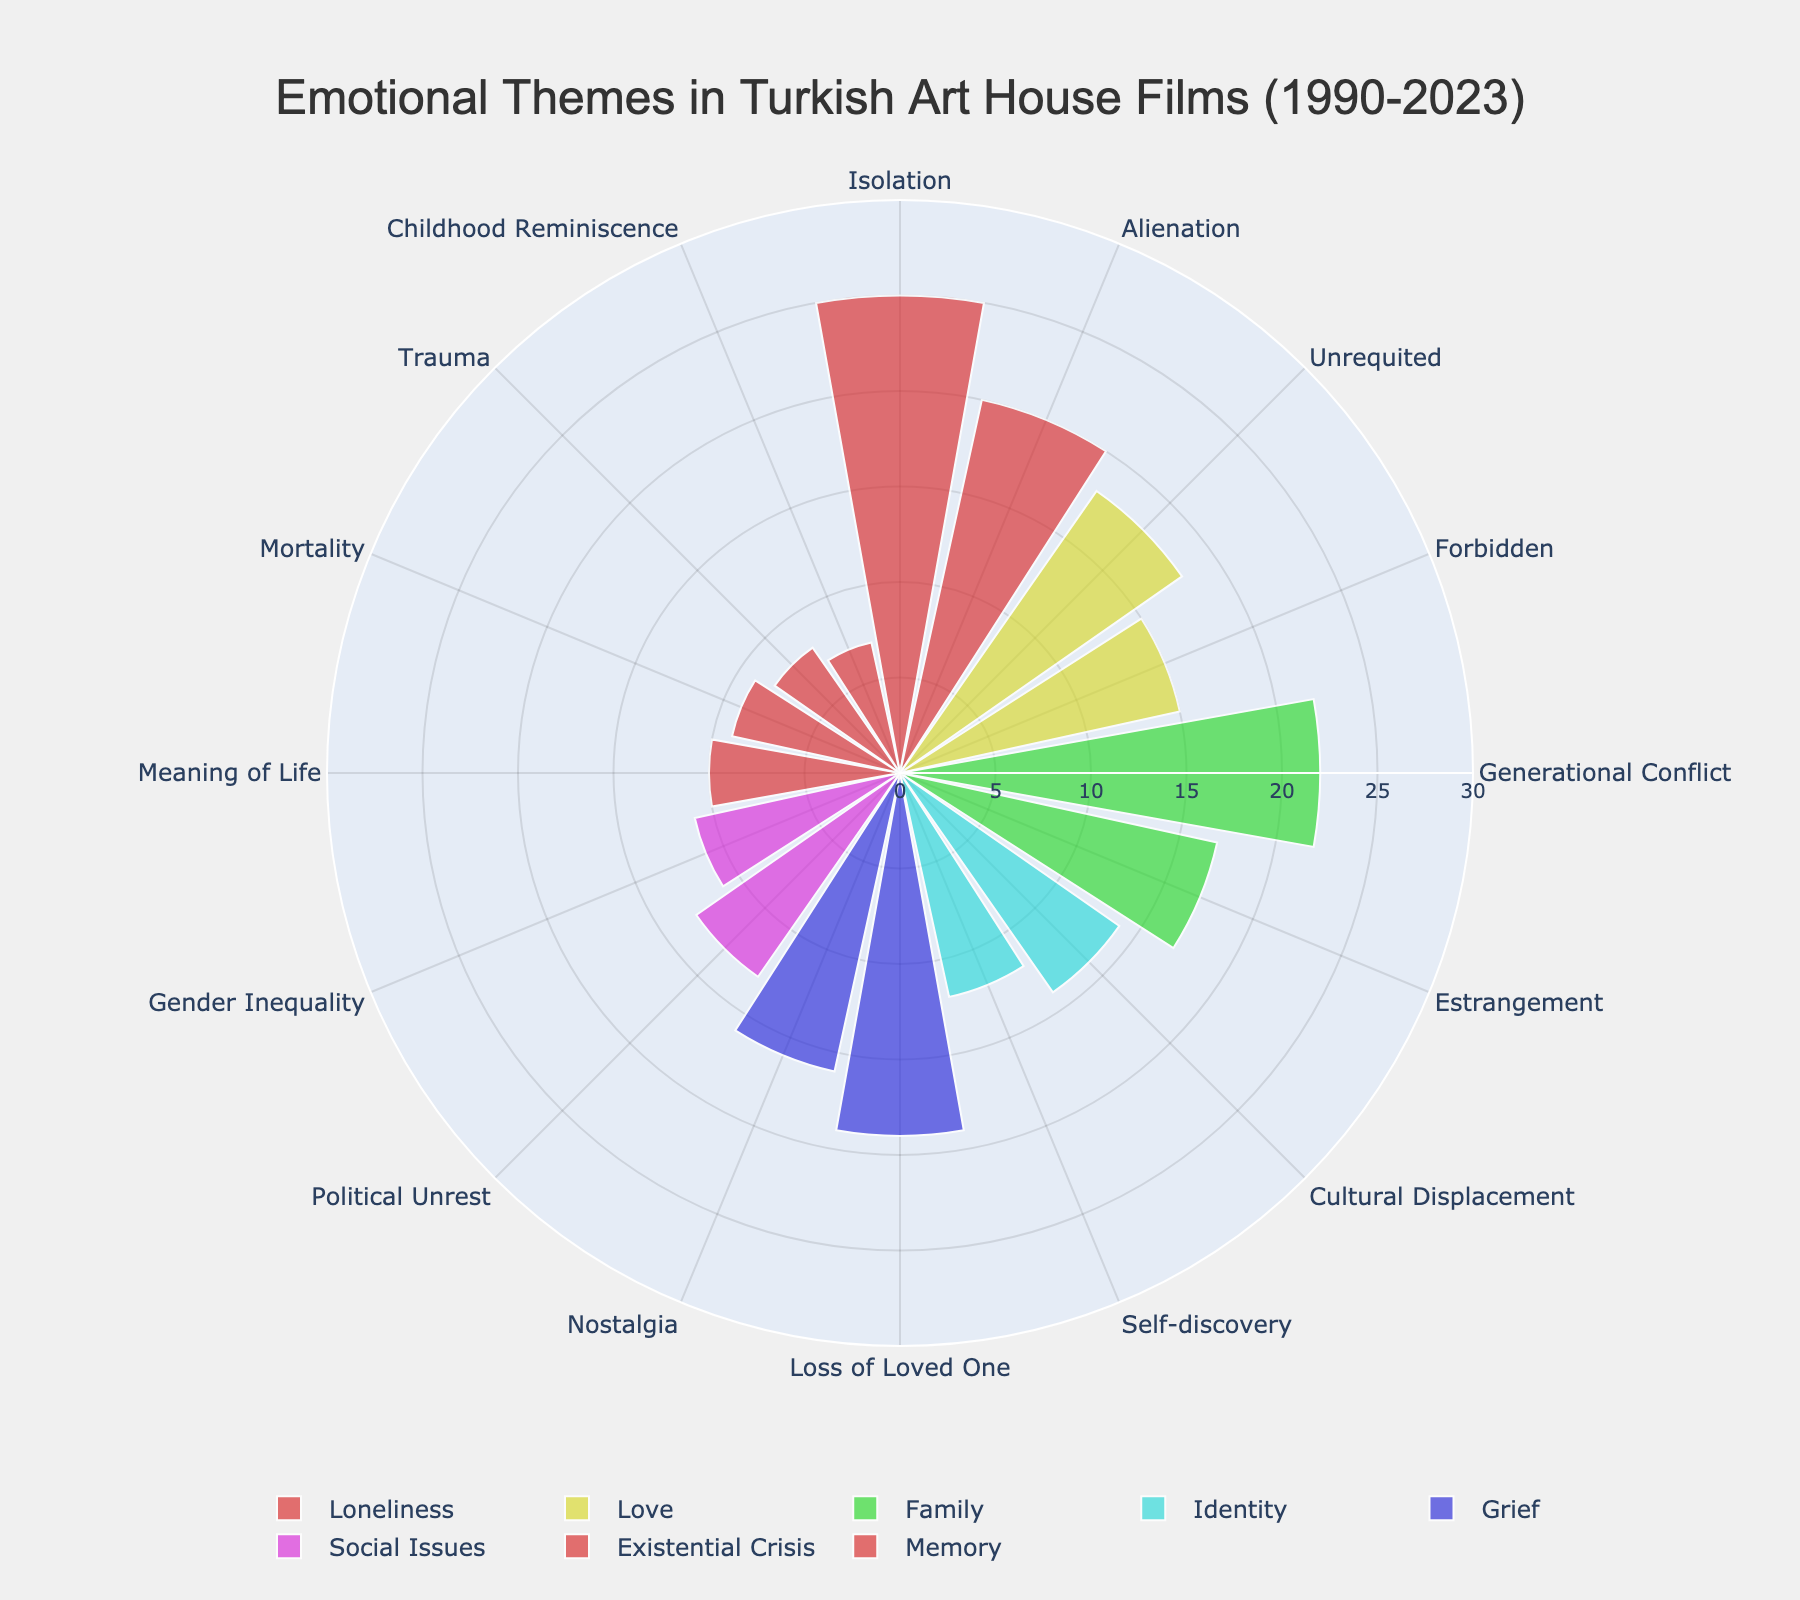What is the highest value present in the chart? Looking at the chart, the highest value corresponds to a bar with the value of 25 in the 'Isolation' subcategory under the 'Loneliness' category.
Answer: 25 How many subcategories are there in total for 'Family' and 'Identity' combined? The 'Family' category has two subcategories: 'Generational Conflict' and 'Estrangement'. The 'Identity' category also has two subcategories: 'Cultural Displacement' and 'Self-discovery'. Adding these together gives us a total of 4 subcategories.
Answer: 4 Which category has the lowest value in one of its subcategories, and what is that value? The chart shows that the 'Memory' category has a subcategory 'Childhood Reminiscence' with the lowest value of 7.
Answer: Memory, 7 What is the combined value of the 'Grief' category? The 'Grief' category has two subcategories: 'Loss of Loved One' with a value of 19 and 'Nostalgia' with a value of 16. Adding these together, we get 19 + 16 = 35.
Answer: 35 Which subcategory has a higher value: 'Unrequited' or 'Forbidden' love? The 'Unrequited' love subcategory has a value of 18, while the 'Forbidden' love subcategory has a value of 15. Comparing these, 'Unrequited' love has a higher value.
Answer: Unrequited How many distinct categories are represented in the chart? The chart shows six distinct categories: 'Loneliness', 'Love', 'Family', 'Identity', 'Grief', 'Social Issues', 'Existential Crisis', and 'Memory'.
Answer: 8 If you average the values of all subcategories under 'Social Issues', what is the average? The 'Social Issues' category has two subcategories: 'Political Unrest' with a value of 13 and 'Gender Inequality' with a value of 11. The average is calculated as (13 + 11) / 2 = 12.
Answer: 12 Which category has both of its subcategories' values adding up the highest? Adding the values of each category's subcategories: Loneliness (25+20=45), Love (18+15=33), Family (22+17=39), Identity (14+12=26), Grief (19+16=35), Social Issues (13+11=24), Existential Crisis (10+9=19), Memory (8+7=15). 'Loneliness' has the highest combined value of 45.
Answer: Loneliness Which subcategory related to 'Existential Crisis' has a higher value, and what is the value? The 'Existential Crisis' category includes the subcategories 'Meaning of Life' with a value of 10 and 'Mortality' with a value of 9. The higher value is in the 'Meaning of Life' subcategory.
Answer: Meaning of Life, 10 